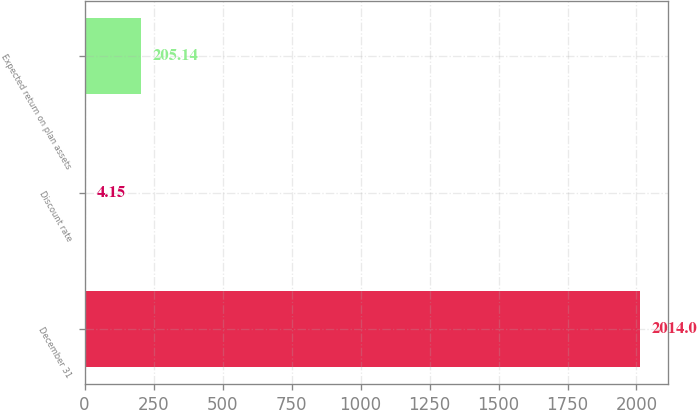Convert chart to OTSL. <chart><loc_0><loc_0><loc_500><loc_500><bar_chart><fcel>December 31<fcel>Discount rate<fcel>Expected return on plan assets<nl><fcel>2014<fcel>4.15<fcel>205.14<nl></chart> 